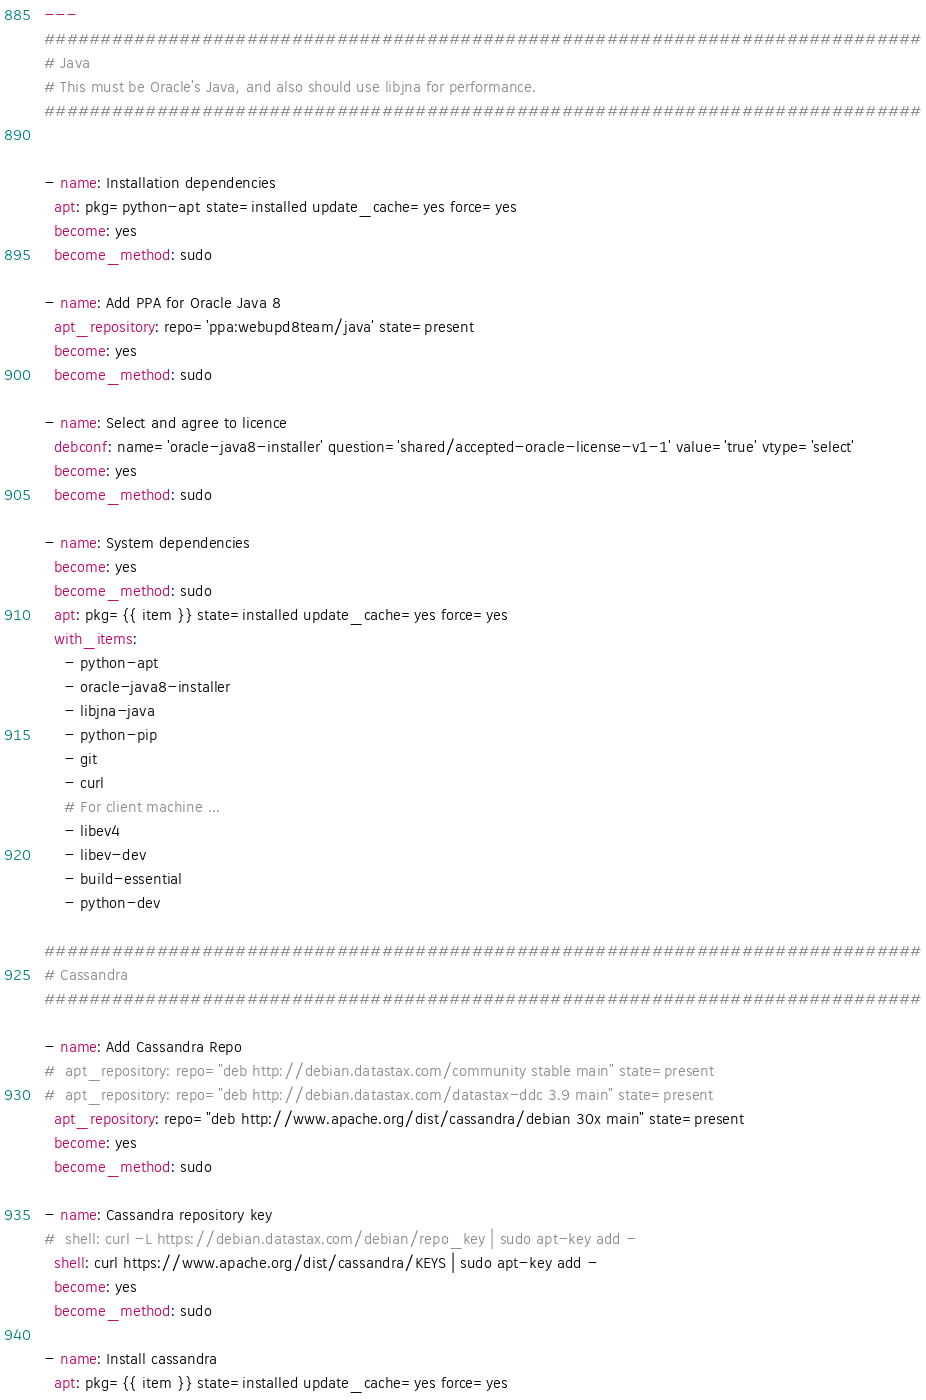<code> <loc_0><loc_0><loc_500><loc_500><_YAML_>---
##############################################################################
# Java
# This must be Oracle's Java, and also should use libjna for performance.
##############################################################################


- name: Installation dependencies
  apt: pkg=python-apt state=installed update_cache=yes force=yes
  become: yes
  become_method: sudo

- name: Add PPA for Oracle Java 8
  apt_repository: repo='ppa:webupd8team/java' state=present
  become: yes
  become_method: sudo

- name: Select and agree to licence
  debconf: name='oracle-java8-installer' question='shared/accepted-oracle-license-v1-1' value='true' vtype='select'
  become: yes
  become_method: sudo

- name: System dependencies
  become: yes
  become_method: sudo
  apt: pkg={{ item }} state=installed update_cache=yes force=yes
  with_items:
    - python-apt
    - oracle-java8-installer
    - libjna-java
    - python-pip
    - git
    - curl
    # For client machine ...
    - libev4
    - libev-dev
    - build-essential
    - python-dev

##############################################################################
# Cassandra
##############################################################################

- name: Add Cassandra Repo
#  apt_repository: repo="deb http://debian.datastax.com/community stable main" state=present
#  apt_repository: repo="deb http://debian.datastax.com/datastax-ddc 3.9 main" state=present
  apt_repository: repo="deb http://www.apache.org/dist/cassandra/debian 30x main" state=present
  become: yes
  become_method: sudo

- name: Cassandra repository key
#  shell: curl -L https://debian.datastax.com/debian/repo_key | sudo apt-key add -
  shell: curl https://www.apache.org/dist/cassandra/KEYS | sudo apt-key add - 
  become: yes
  become_method: sudo

- name: Install cassandra
  apt: pkg={{ item }} state=installed update_cache=yes force=yes</code> 